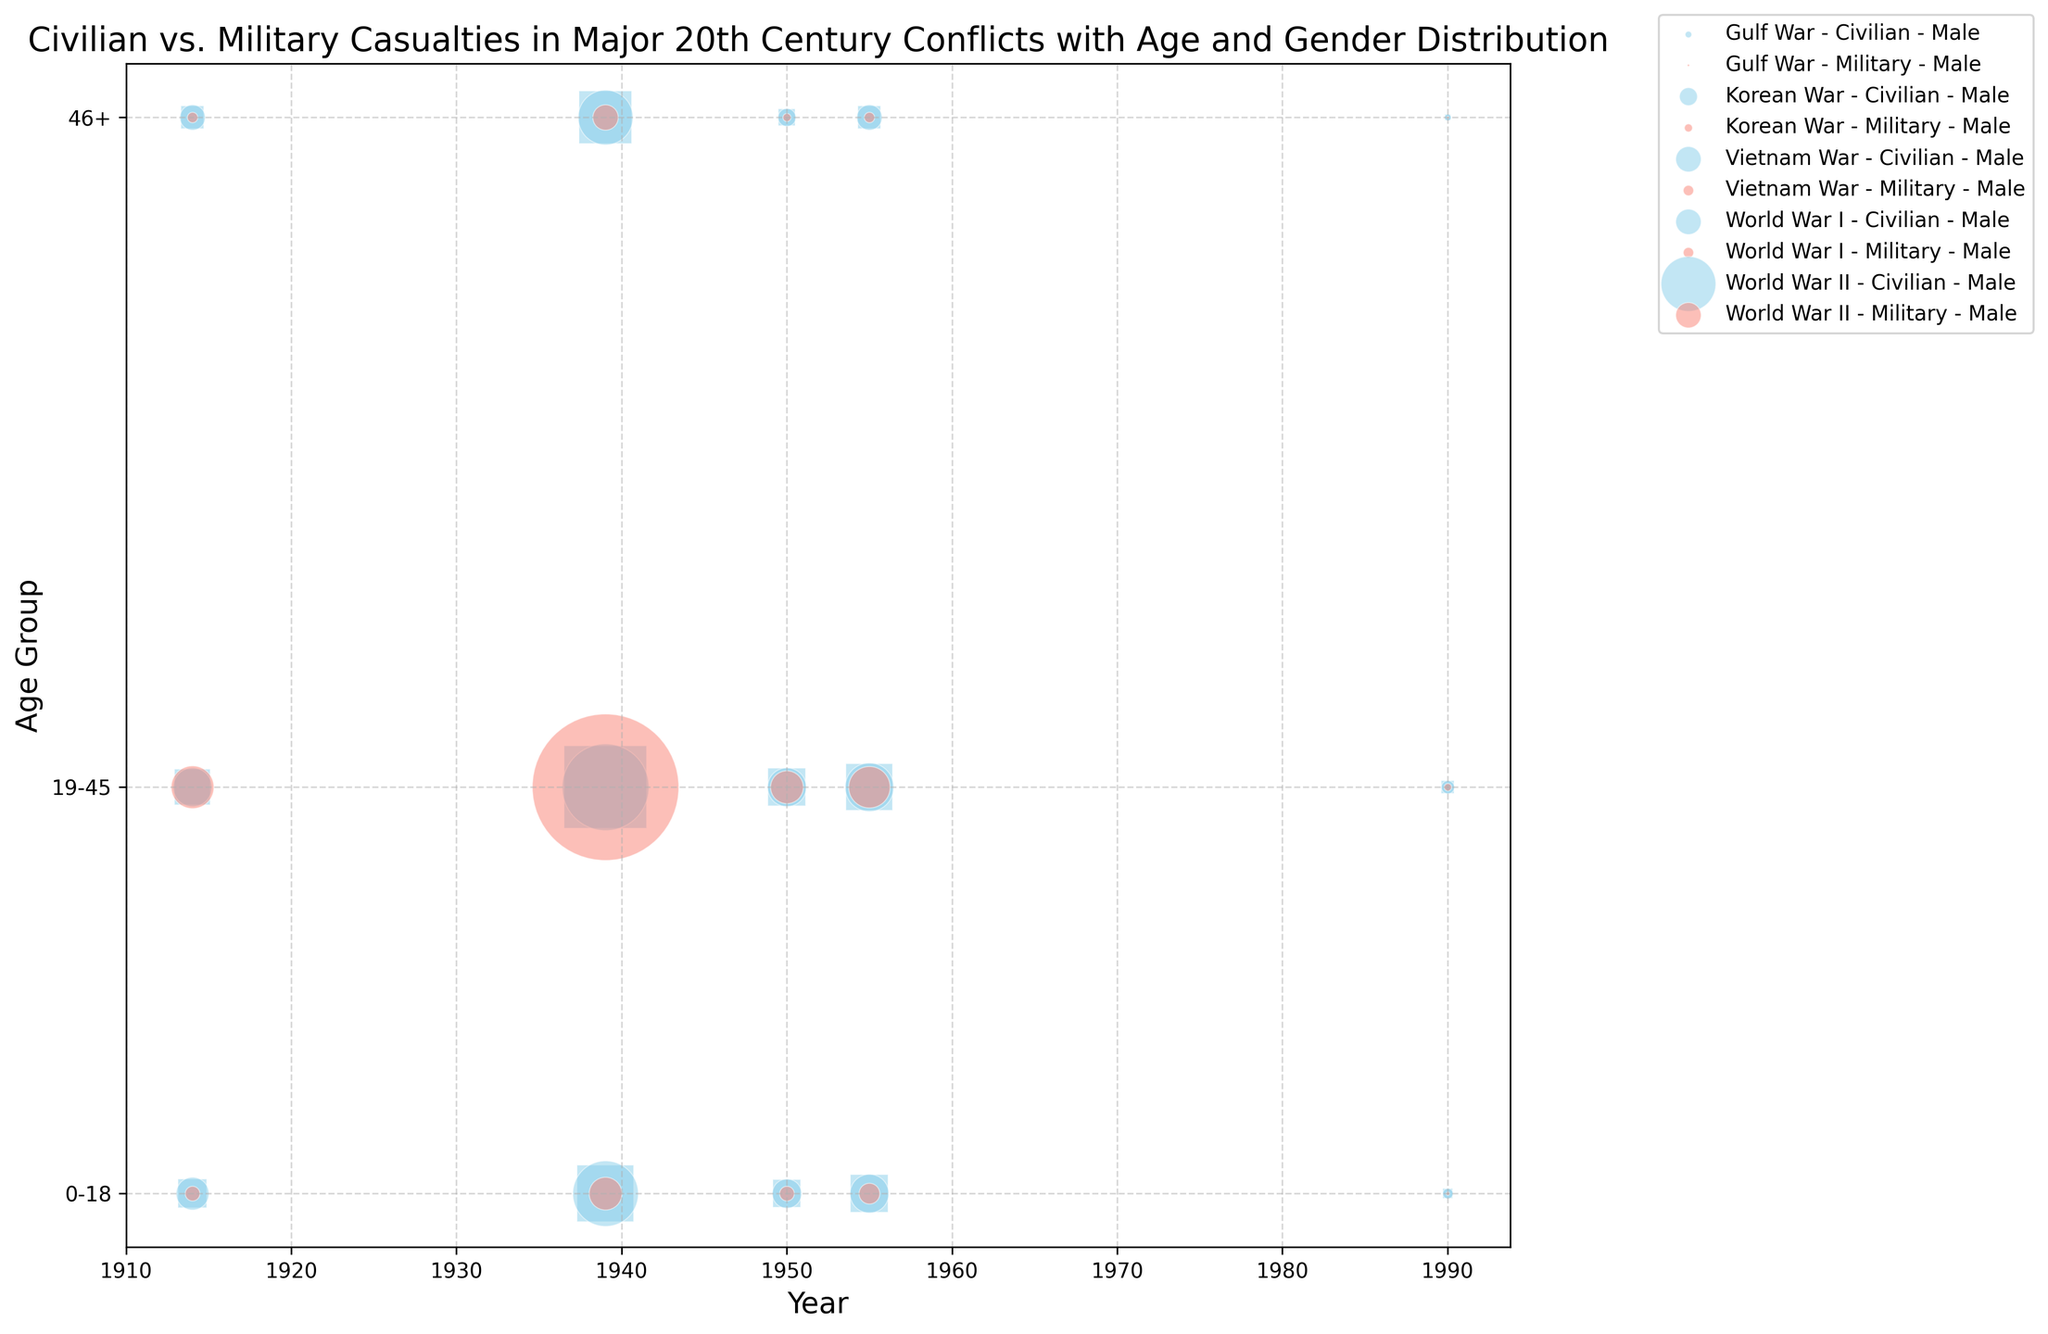What conflicts are represented by markers with the largest size? The largest markers in the figure represent the number of casualties. By comparing the sizes visually, we can observe that World War II has the largest bubbles, which indicate the highest number of casualties.
Answer: World War II How does the casualty count for Korean War civilians aged 0-18 compare to Gulf War civilians aged 0-18? To determine this, we need to compare the bubble sizes for the two groups. Visual inspection of the figure shows that the bubbles for Korean War civilians aged 0-18 are significantly larger than those for Gulf War civilians aged 0-18.
Answer: Korean War civilians aged 0-18 have more casualties than Gulf War civilians aged 0-18 Which age group of military casualties in World War II had the least representation? We need to compare the markers for different age groups among military casualties during World War II. The smallest markers correspond to the age group of 46+ years.
Answer: Age group 46+ What is the approximate ratio of male to female civilian casualties aged 19-45 in the Vietnam War? To find this ratio, we compare the sizes of the male and female civilian casualties aged 19-45 bubbles in the Vietnam War. The male bubble is slightly larger than the female bubble. Given the total casualties of 1100000 (male) and 1000000 (female), the ratio is approximately 1.1:1.
Answer: 1.1:1 During which conflict did military casualties for the age group 19-45 see the highest representation? Comparing the size of bubbles for military casualties aged 19-45 across the conflicts in the figure, World War II stands out with the largest bubbles.
Answer: World War II What is the total number of male civilian casualties aged 19-45 across all conflicts? By adding the total male civilian casualties aged 19-45 for each conflict: WWI (700000), WWII (3500000), Korean War (700000), Vietnam War (1100000), Gulf War (80000), we get \(700000 + 3500000 + 700000 + 1100000 + 80000 = 6080000\).
Answer: 6080000 Compare the size and opacity of bubbles representing male and female military casualties in the Korean War. The figure's bubbles for male and female military casualties in the Korean War indicate their relative sizes. Male casualties in the bubbles are larger and have higher opacity compared to female bubbles, suggesting there are more male casualties in the military.
Answer: Male casualties have larger and more opaque bubbles What's the difference in size between civilian and military casualties aged 0-18 during the Gulf War? For the Gulf War, compare the sizes of bubbles for civilian (50000 + 45000 = 95000) and military (5000) casualties aged 0-18. The civilian bubble is much larger. The total difference is \(95000 - 5000 = 90000\).
Answer: 90000 